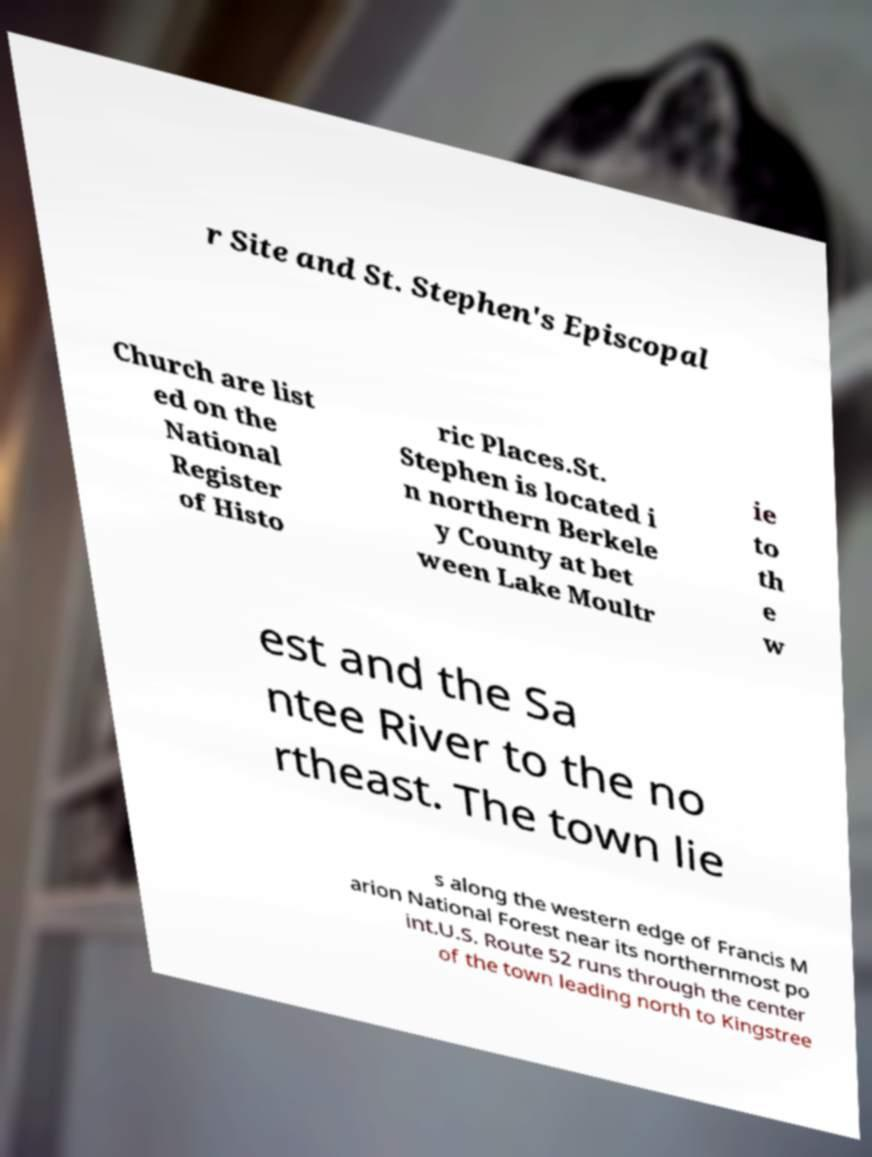There's text embedded in this image that I need extracted. Can you transcribe it verbatim? r Site and St. Stephen's Episcopal Church are list ed on the National Register of Histo ric Places.St. Stephen is located i n northern Berkele y County at bet ween Lake Moultr ie to th e w est and the Sa ntee River to the no rtheast. The town lie s along the western edge of Francis M arion National Forest near its northernmost po int.U.S. Route 52 runs through the center of the town leading north to Kingstree 